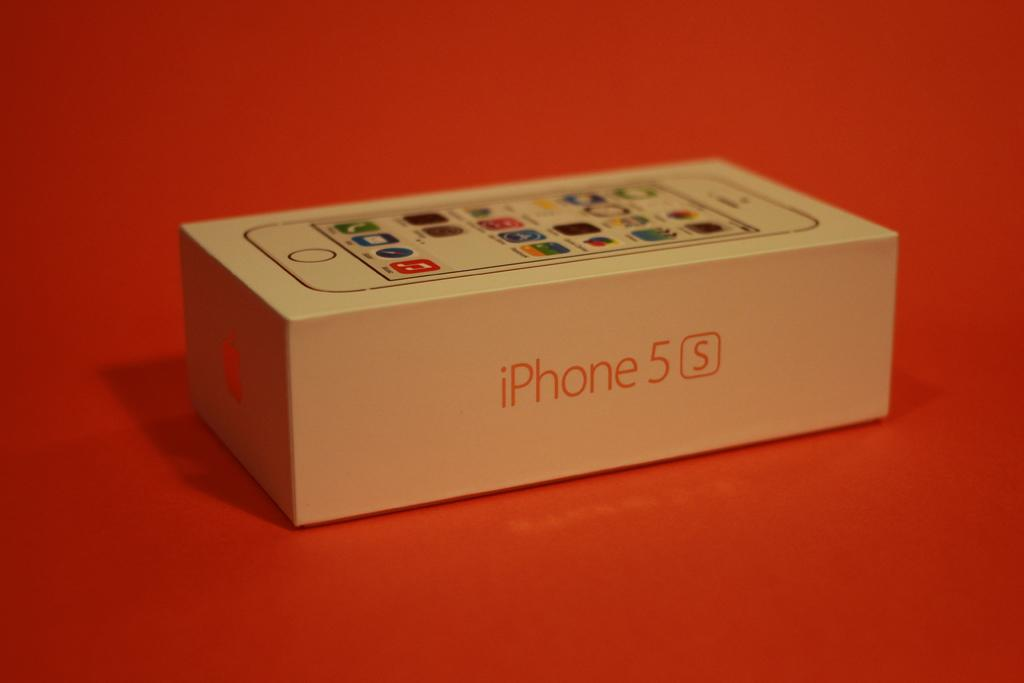<image>
Describe the image concisely. A white box reads "iPhone 5 S" on the side. 